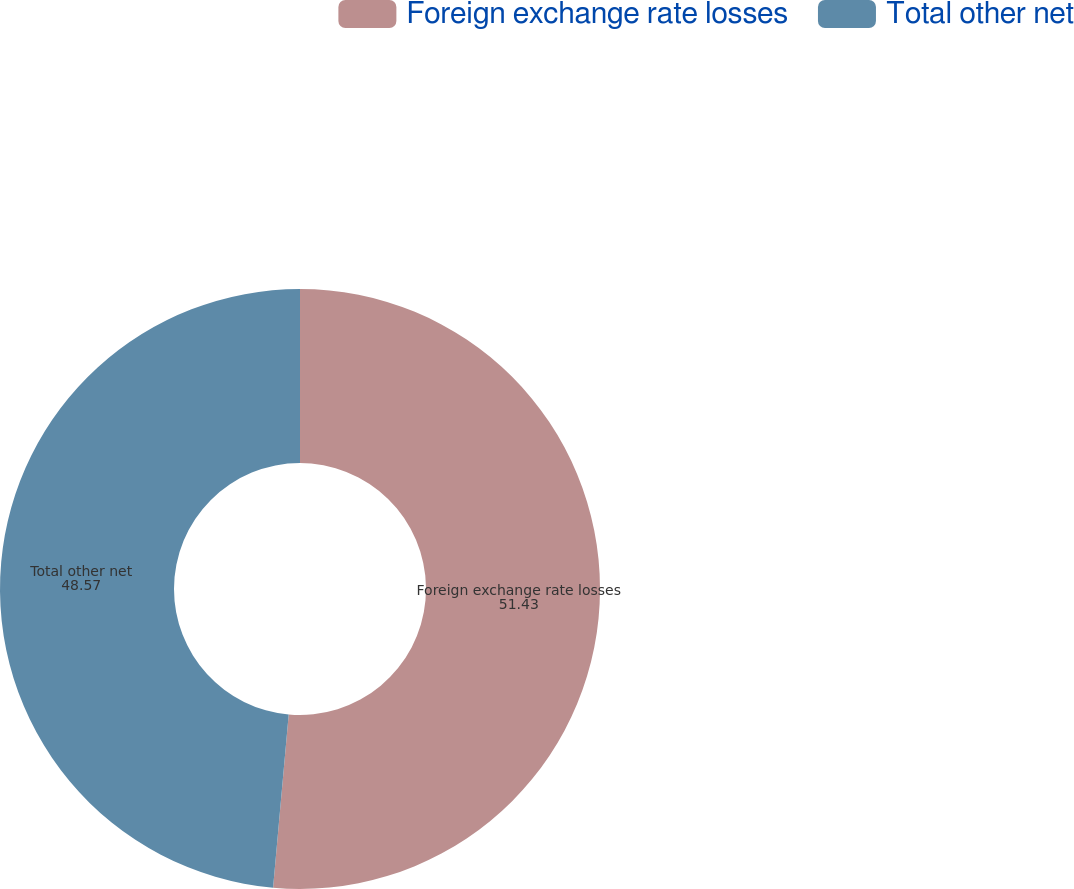Convert chart. <chart><loc_0><loc_0><loc_500><loc_500><pie_chart><fcel>Foreign exchange rate losses<fcel>Total other net<nl><fcel>51.43%<fcel>48.57%<nl></chart> 